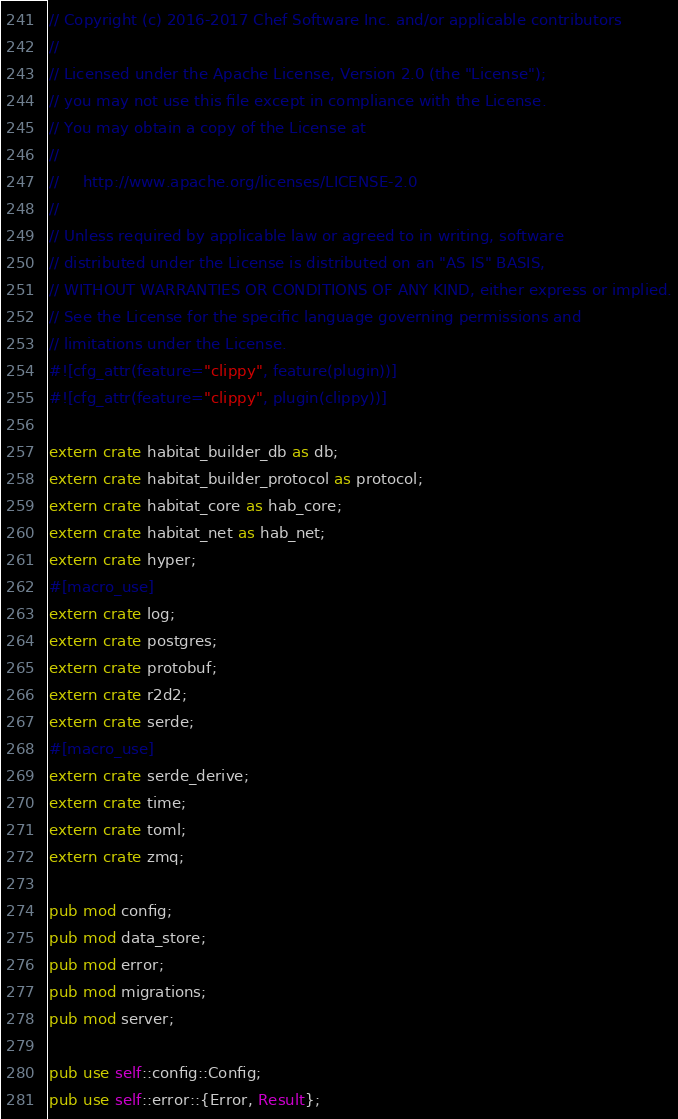Convert code to text. <code><loc_0><loc_0><loc_500><loc_500><_Rust_>// Copyright (c) 2016-2017 Chef Software Inc. and/or applicable contributors
//
// Licensed under the Apache License, Version 2.0 (the "License");
// you may not use this file except in compliance with the License.
// You may obtain a copy of the License at
//
//     http://www.apache.org/licenses/LICENSE-2.0
//
// Unless required by applicable law or agreed to in writing, software
// distributed under the License is distributed on an "AS IS" BASIS,
// WITHOUT WARRANTIES OR CONDITIONS OF ANY KIND, either express or implied.
// See the License for the specific language governing permissions and
// limitations under the License.
#![cfg_attr(feature="clippy", feature(plugin))]
#![cfg_attr(feature="clippy", plugin(clippy))]

extern crate habitat_builder_db as db;
extern crate habitat_builder_protocol as protocol;
extern crate habitat_core as hab_core;
extern crate habitat_net as hab_net;
extern crate hyper;
#[macro_use]
extern crate log;
extern crate postgres;
extern crate protobuf;
extern crate r2d2;
extern crate serde;
#[macro_use]
extern crate serde_derive;
extern crate time;
extern crate toml;
extern crate zmq;

pub mod config;
pub mod data_store;
pub mod error;
pub mod migrations;
pub mod server;

pub use self::config::Config;
pub use self::error::{Error, Result};
</code> 